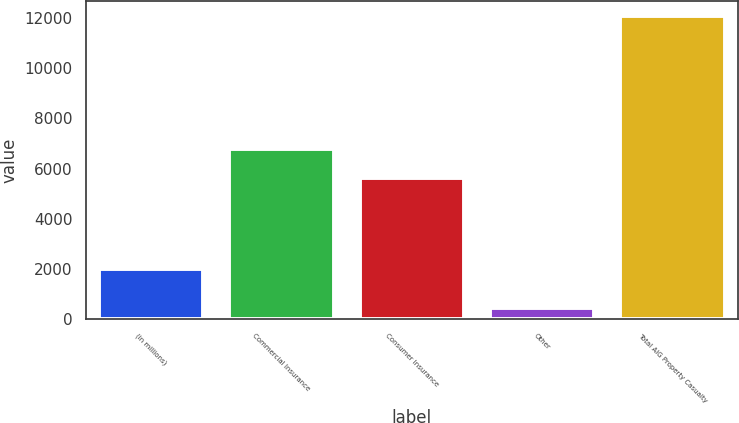Convert chart. <chart><loc_0><loc_0><loc_500><loc_500><bar_chart><fcel>(in millions)<fcel>Commercial Insurance<fcel>Consumer Insurance<fcel>Other<fcel>Total AIG Property Casualty<nl><fcel>2012<fcel>6775.2<fcel>5613<fcel>466<fcel>12088<nl></chart> 